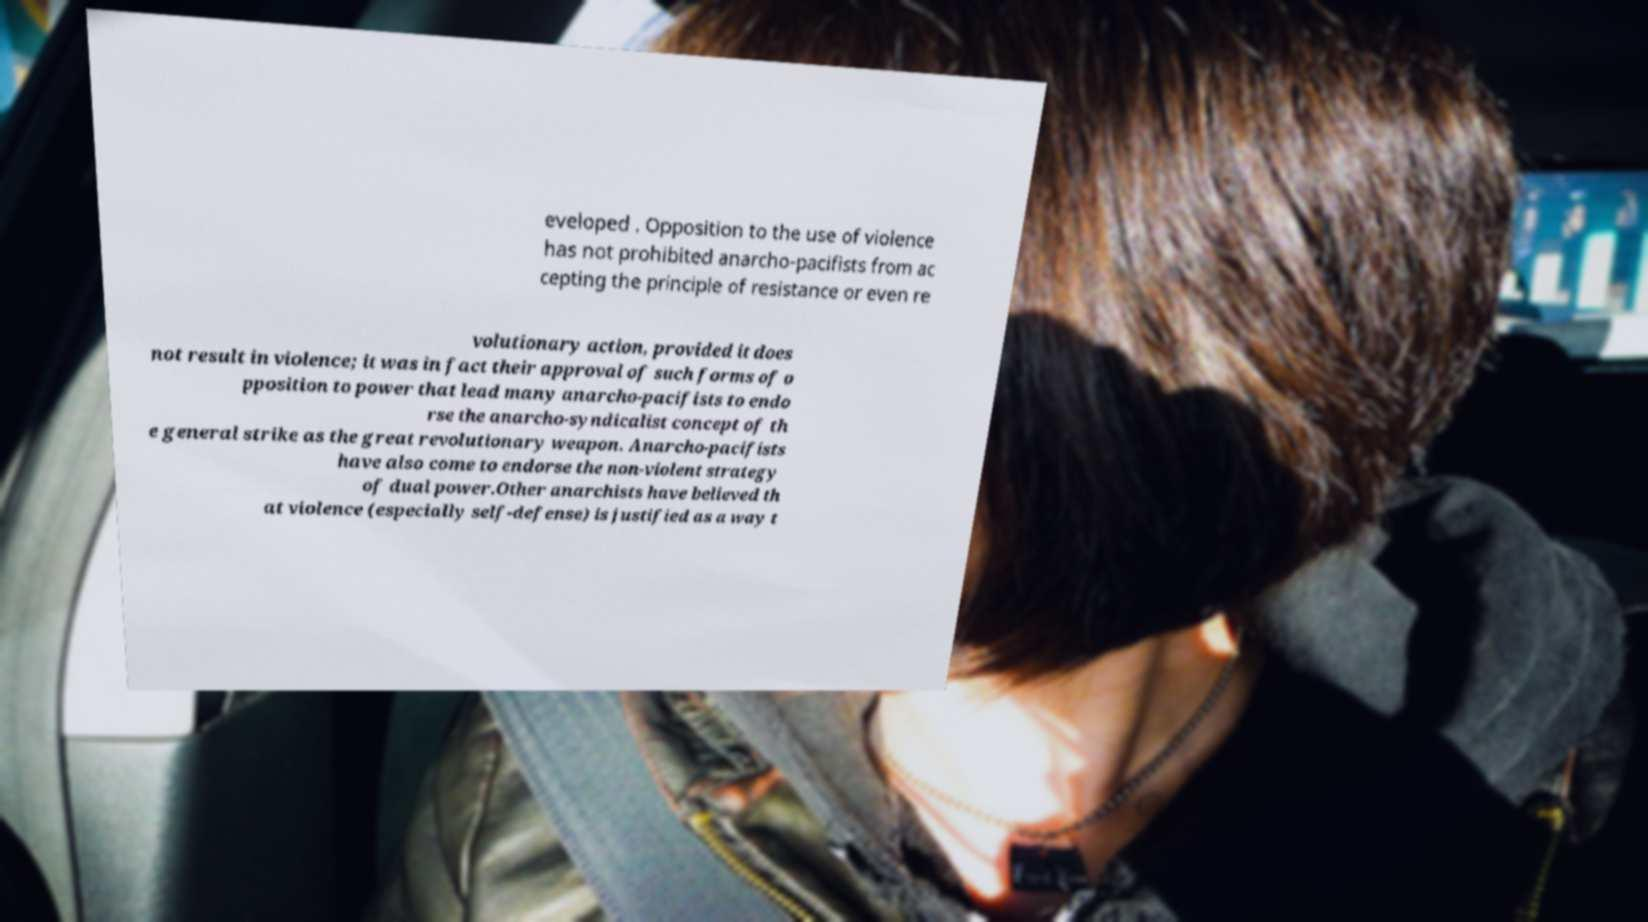Please read and relay the text visible in this image. What does it say? eveloped . Opposition to the use of violence has not prohibited anarcho-pacifists from ac cepting the principle of resistance or even re volutionary action, provided it does not result in violence; it was in fact their approval of such forms of o pposition to power that lead many anarcho-pacifists to endo rse the anarcho-syndicalist concept of th e general strike as the great revolutionary weapon. Anarcho-pacifists have also come to endorse the non-violent strategy of dual power.Other anarchists have believed th at violence (especially self-defense) is justified as a way t 